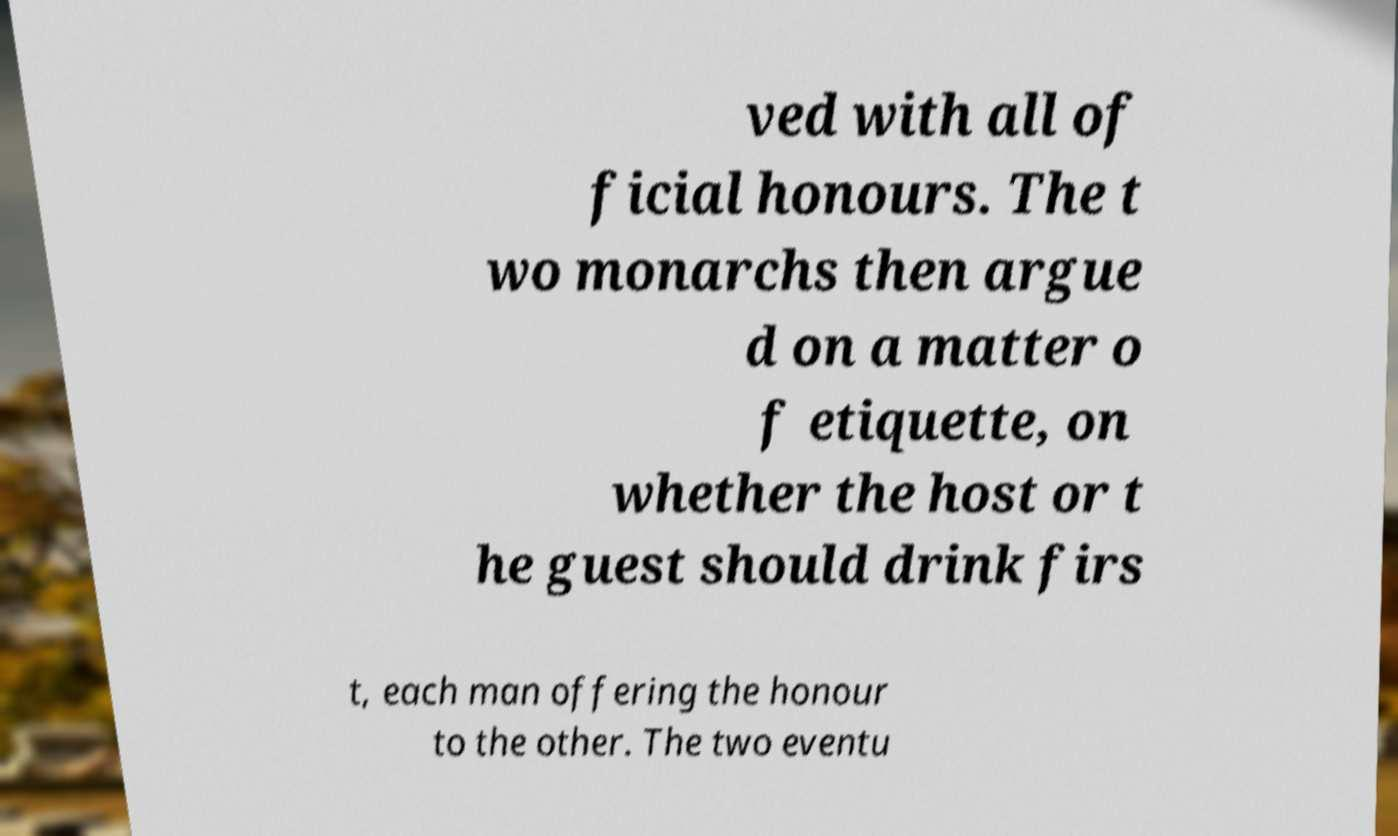Could you assist in decoding the text presented in this image and type it out clearly? ved with all of ficial honours. The t wo monarchs then argue d on a matter o f etiquette, on whether the host or t he guest should drink firs t, each man offering the honour to the other. The two eventu 